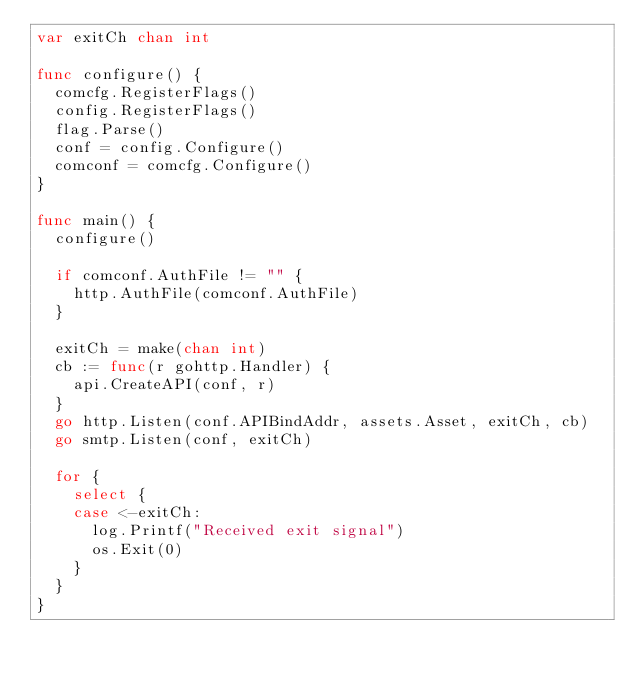<code> <loc_0><loc_0><loc_500><loc_500><_Go_>var exitCh chan int

func configure() {
	comcfg.RegisterFlags()
	config.RegisterFlags()
	flag.Parse()
	conf = config.Configure()
	comconf = comcfg.Configure()
}

func main() {
	configure()

	if comconf.AuthFile != "" {
		http.AuthFile(comconf.AuthFile)
	}

	exitCh = make(chan int)
	cb := func(r gohttp.Handler) {
		api.CreateAPI(conf, r)
	}
	go http.Listen(conf.APIBindAddr, assets.Asset, exitCh, cb)
	go smtp.Listen(conf, exitCh)

	for {
		select {
		case <-exitCh:
			log.Printf("Received exit signal")
			os.Exit(0)
		}
	}
}
</code> 